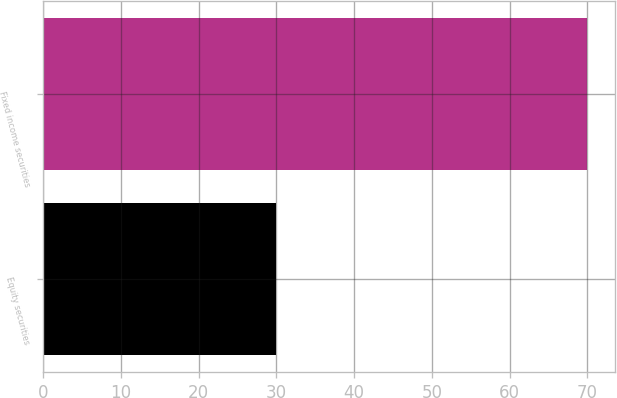<chart> <loc_0><loc_0><loc_500><loc_500><bar_chart><fcel>Equity securities<fcel>Fixed income securities<nl><fcel>30<fcel>70<nl></chart> 